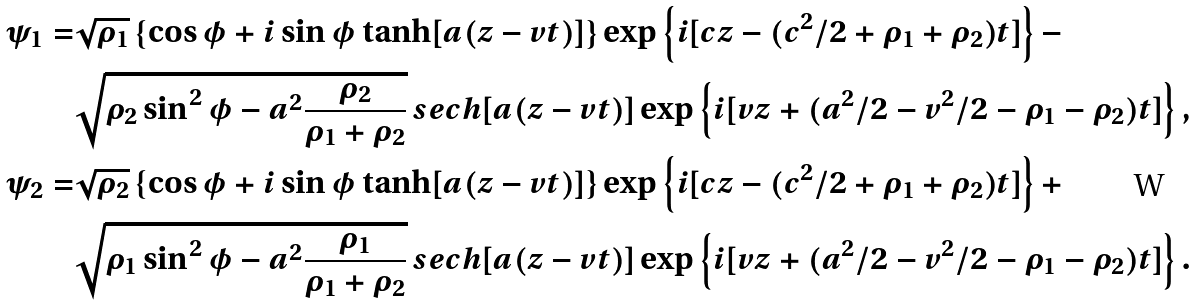Convert formula to latex. <formula><loc_0><loc_0><loc_500><loc_500>\psi _ { 1 } = & \sqrt { \rho _ { 1 } } \left \{ \cos \phi + i \sin \phi \tanh [ a ( z - v t ) ] \right \} \exp \left \{ i [ c z - ( c ^ { 2 } / 2 + \rho _ { 1 } + \rho _ { 2 } ) t ] \right \} - \\ & \sqrt { \rho _ { 2 } \sin ^ { 2 } \phi - a ^ { 2 } \frac { \rho _ { 2 } } { \rho _ { 1 } + \rho _ { 2 } } } \, s e c h [ a ( z - v t ) ] \exp \left \{ i [ v z + ( a ^ { 2 } / 2 - v ^ { 2 } / 2 - \rho _ { 1 } - \rho _ { 2 } ) t ] \right \} , \\ \psi _ { 2 } = & \sqrt { \rho _ { 2 } } \left \{ \cos \phi + i \sin \phi \tanh [ a ( z - v t ) ] \right \} \exp \left \{ i [ c z - ( c ^ { 2 } / 2 + \rho _ { 1 } + \rho _ { 2 } ) t ] \right \} + \\ & \sqrt { \rho _ { 1 } \sin ^ { 2 } \phi - a ^ { 2 } \frac { \rho _ { 1 } } { \rho _ { 1 } + \rho _ { 2 } } } \, s e c h [ a ( z - v t ) ] \exp \left \{ i [ v z + ( a ^ { 2 } / 2 - v ^ { 2 } / 2 - \rho _ { 1 } - \rho _ { 2 } ) t ] \right \} .</formula> 